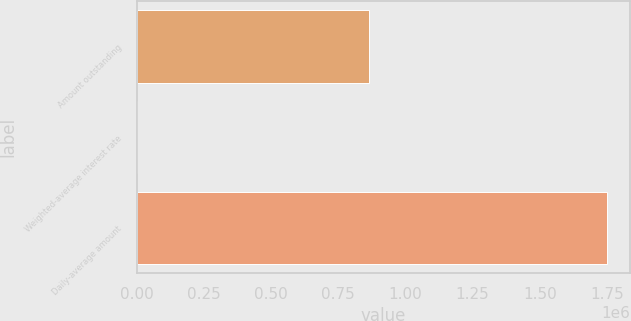Convert chart. <chart><loc_0><loc_0><loc_500><loc_500><bar_chart><fcel>Amount outstanding<fcel>Weighted-average interest rate<fcel>Daily-average amount<nl><fcel>866555<fcel>0.19<fcel>1.74952e+06<nl></chart> 